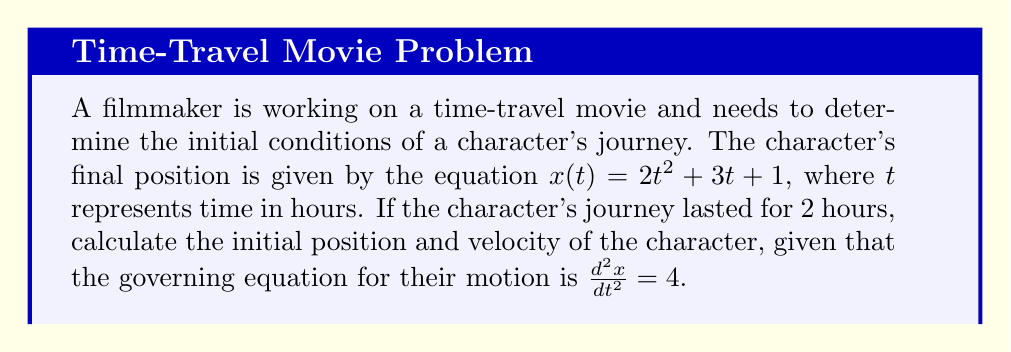Solve this math problem. 1) We start with the given final position equation:
   $x(t) = 2t^2 + 3t + 1$

2) The governing equation states that $\frac{d^2x}{dt^2} = 4$. This matches our position equation, as the second derivative of $x(t)$ is indeed 4:
   $\frac{dx}{dt} = 4t + 3$
   $\frac{d^2x}{dt^2} = 4$

3) To find the initial position, we evaluate $x(t)$ at $t=0$:
   $x(0) = 2(0)^2 + 3(0) + 1 = 1$

4) To find the initial velocity, we evaluate $\frac{dx}{dt}$ at $t=0$:
   $\frac{dx}{dt}(0) = 4(0) + 3 = 3$

Therefore, the initial position is 1 unit, and the initial velocity is 3 units per hour.
Answer: Initial position: 1 unit; Initial velocity: 3 units/hour 